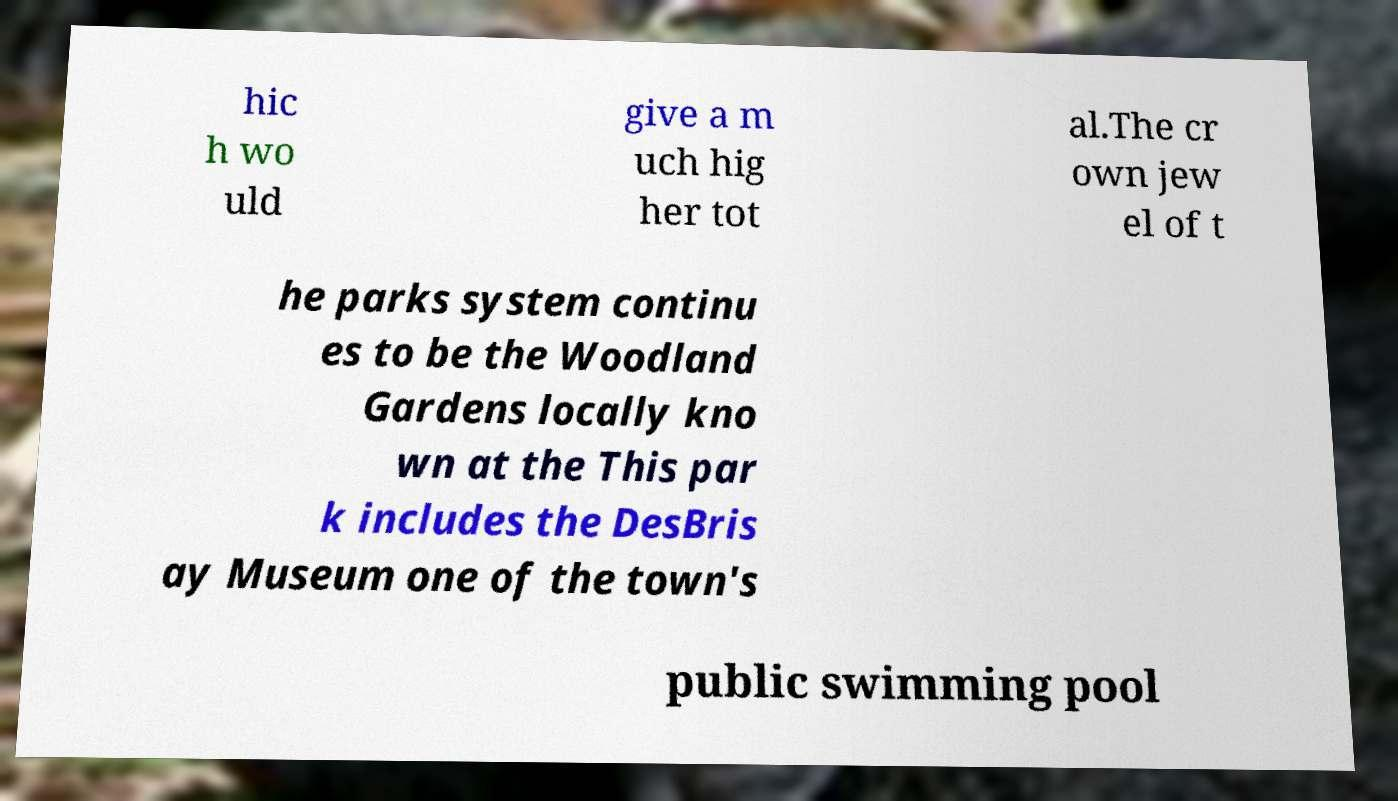For documentation purposes, I need the text within this image transcribed. Could you provide that? hic h wo uld give a m uch hig her tot al.The cr own jew el of t he parks system continu es to be the Woodland Gardens locally kno wn at the This par k includes the DesBris ay Museum one of the town's public swimming pool 